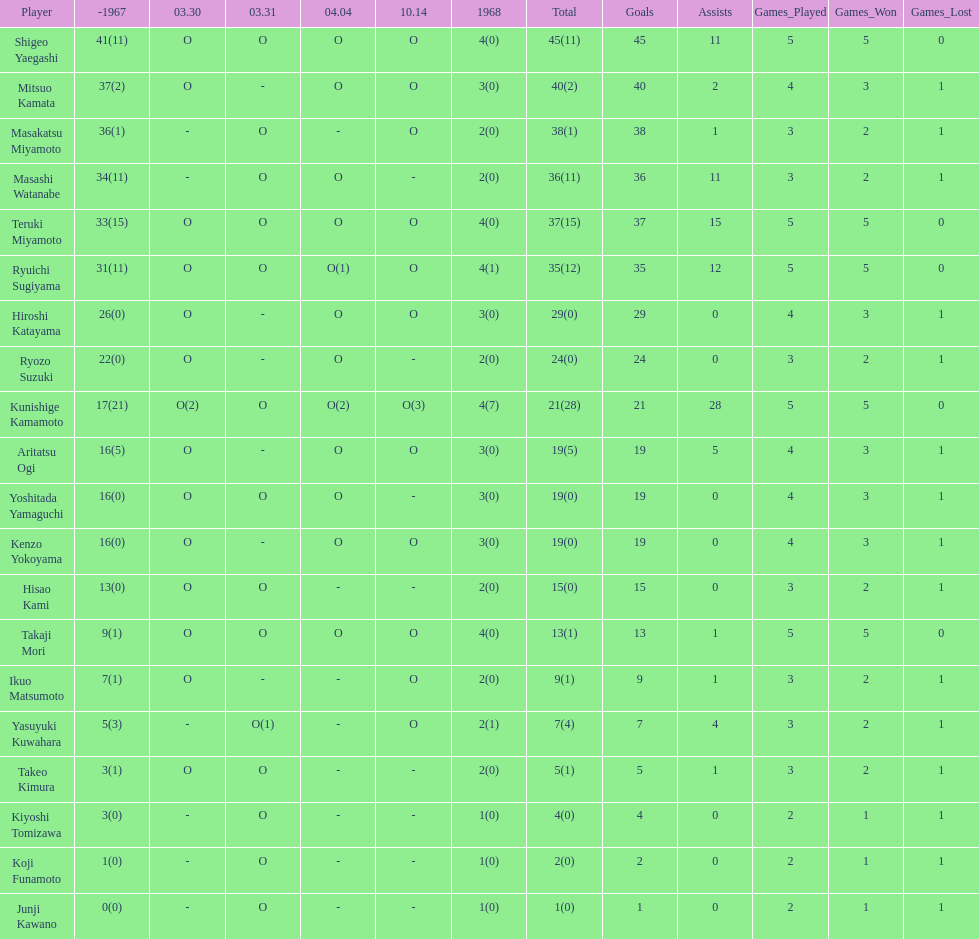Total appearances by masakatsu miyamoto? 38. 